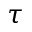<formula> <loc_0><loc_0><loc_500><loc_500>\tau</formula> 